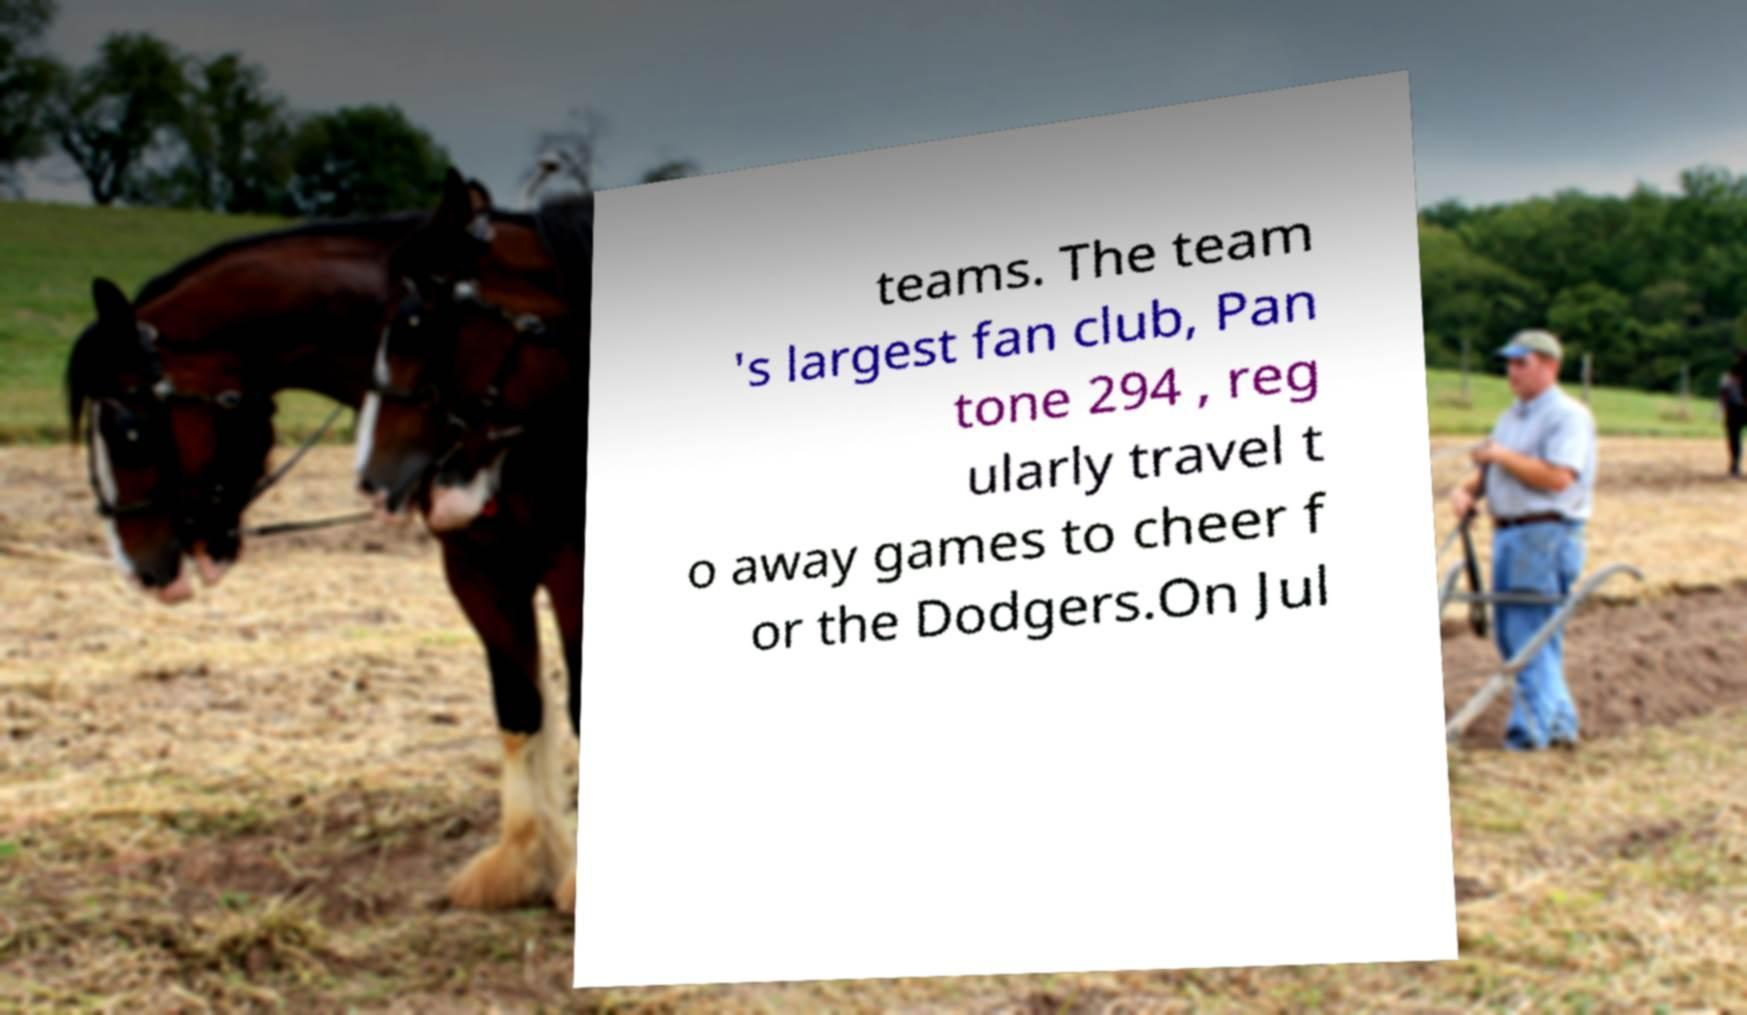Could you extract and type out the text from this image? teams. The team 's largest fan club, Pan tone 294 , reg ularly travel t o away games to cheer f or the Dodgers.On Jul 